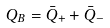<formula> <loc_0><loc_0><loc_500><loc_500>Q _ { B } & = \bar { Q } _ { + } + \bar { Q } _ { - }</formula> 